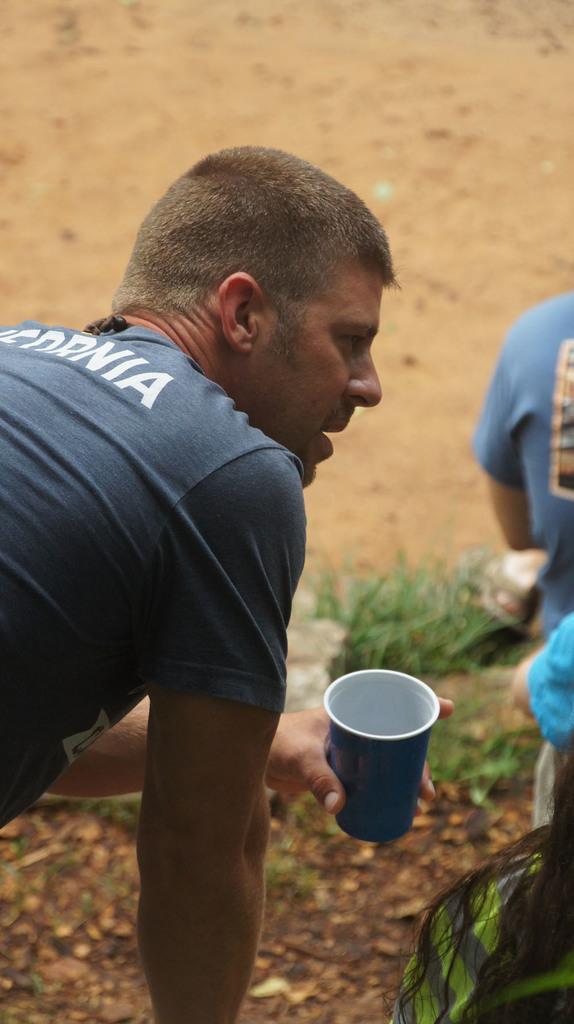How would you summarize this image in a sentence or two? As we can see in the image there is grass, three people and glass. 